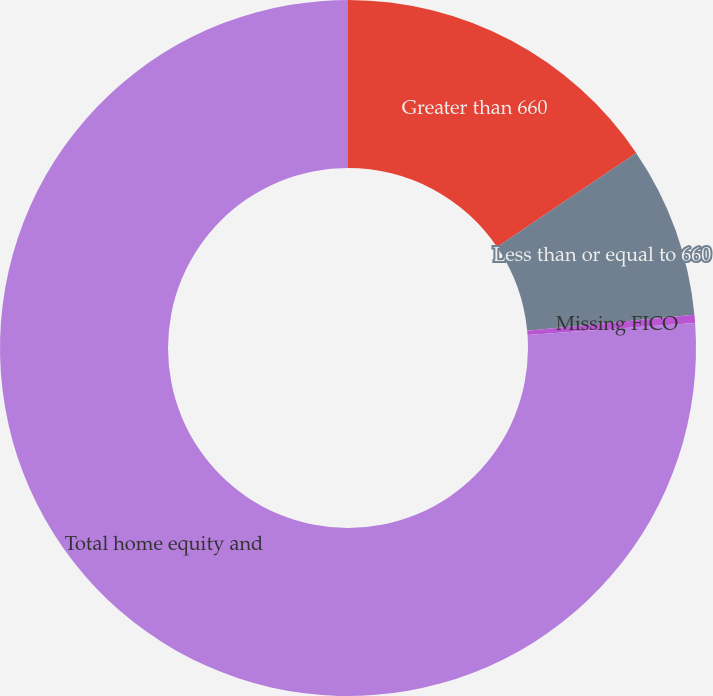Convert chart. <chart><loc_0><loc_0><loc_500><loc_500><pie_chart><fcel>Greater than 660<fcel>Less than or equal to 660<fcel>Missing FICO<fcel>Total home equity and<nl><fcel>15.53%<fcel>7.95%<fcel>0.38%<fcel>76.14%<nl></chart> 